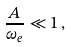<formula> <loc_0><loc_0><loc_500><loc_500>\frac { A } { \omega _ { e } } \ll 1 \, ,</formula> 